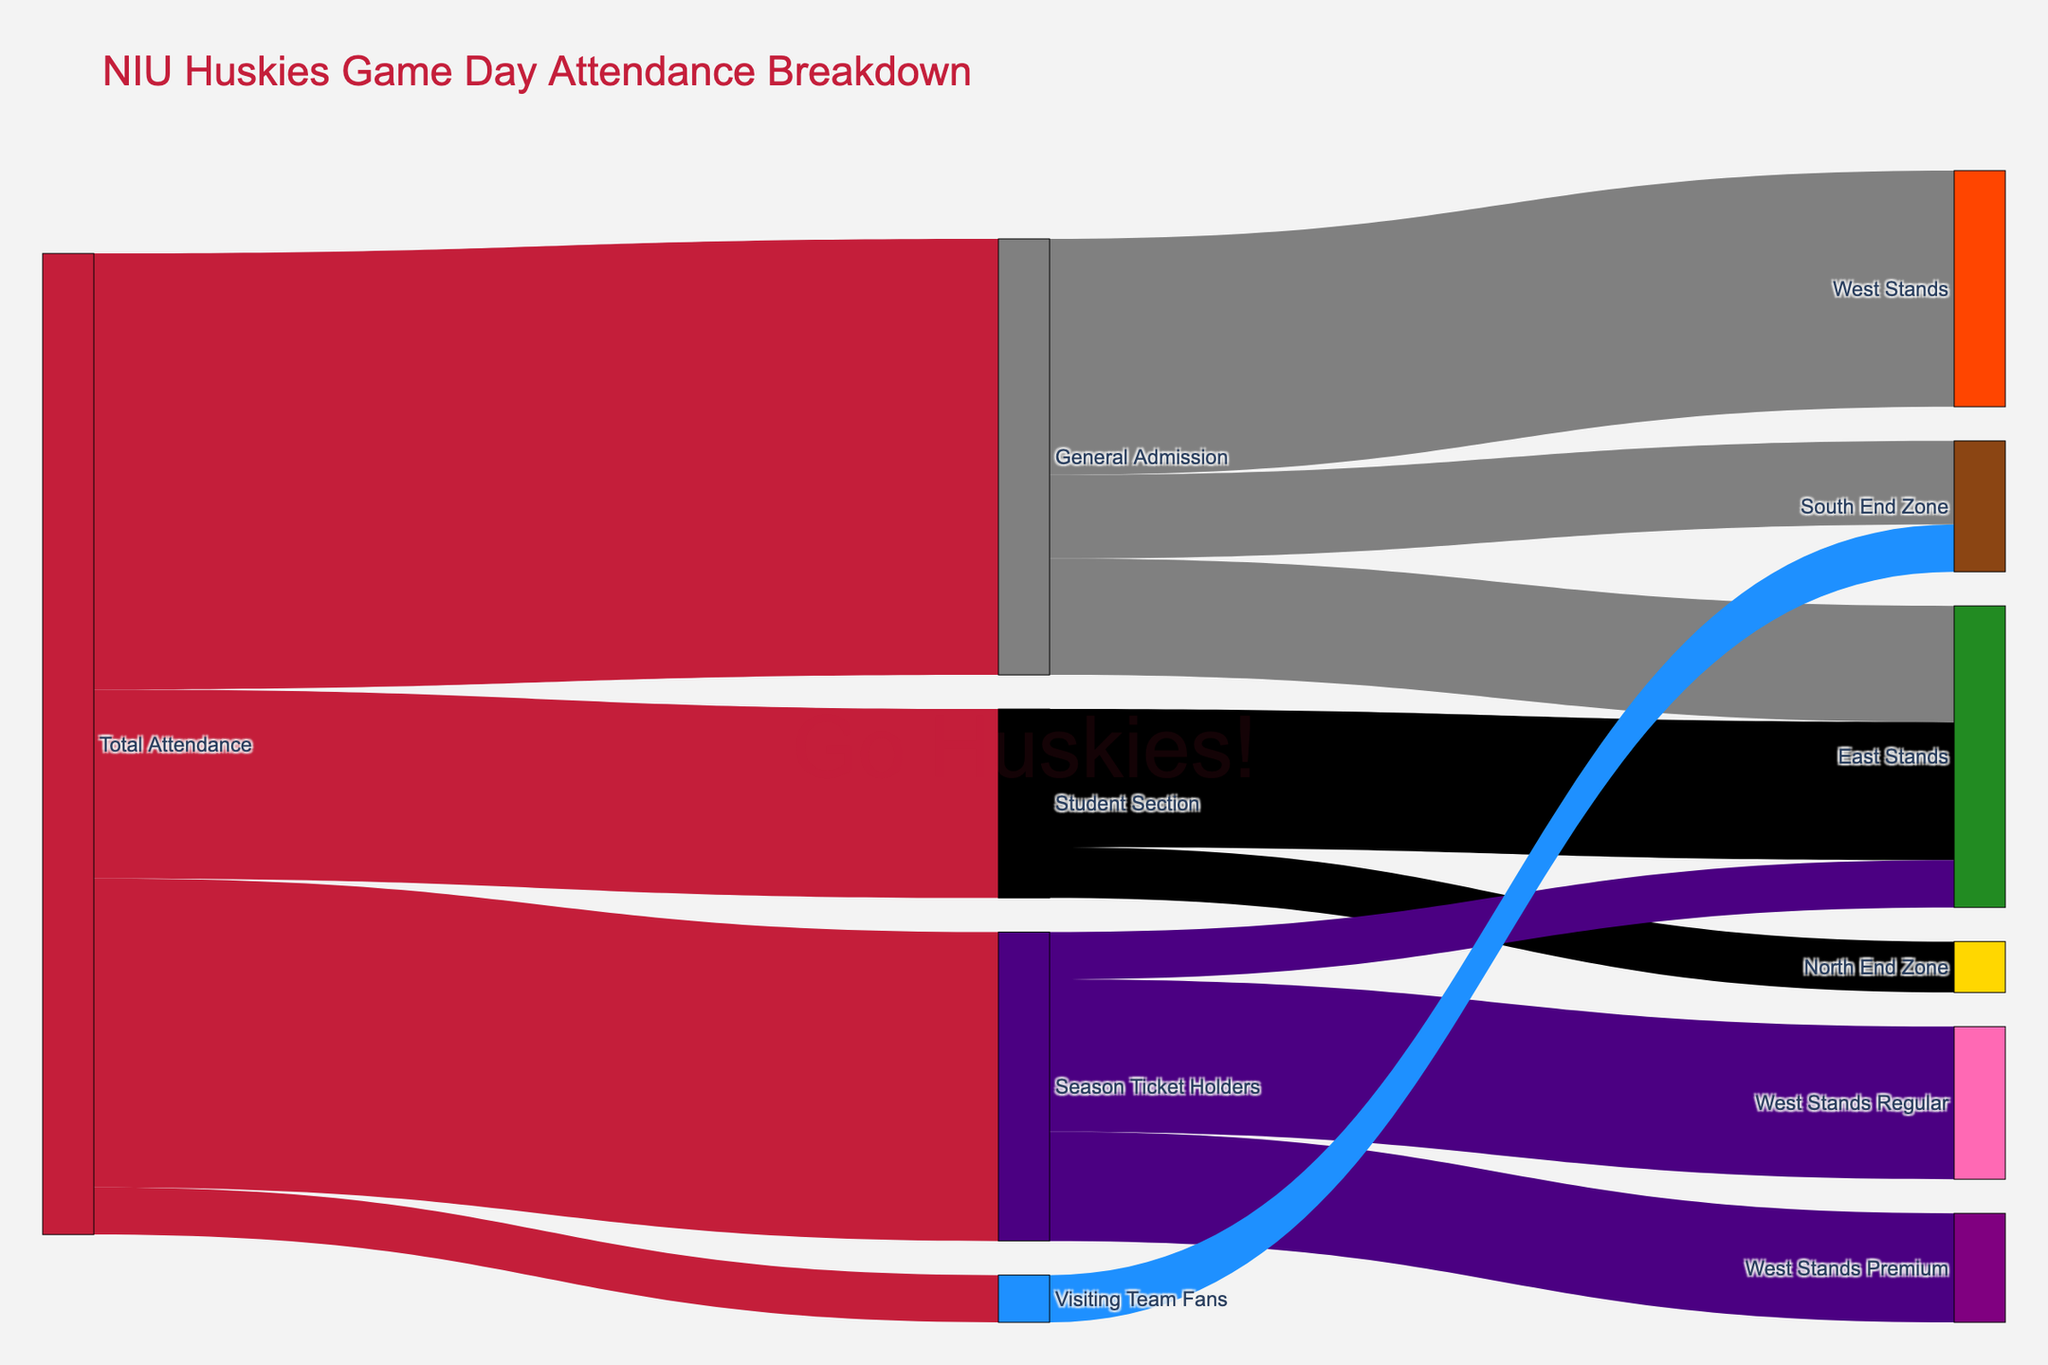What's the total attendance at the game? The source labeled "Total Attendance" flows into different sections of seating. Sum up all the values flowing from "Total Attendance": 5200 (Student Section) + 12000 (General Admission) + 8500 (Season Ticket Holders) + 1300 (Visiting Team Fans).
Answer: 27,000 How many fans are in the Student Section's East Stands? Look for the value connecting "Student Section" to "East Stands".
Answer: 3,800 Which section holds the largest number of General Admission fans? Check the values under "General Admission". The largest value is for "West Stands" with 6,500.
Answer: West Stands Among the Season Ticket Holders, which subsection has the least amount of fans? Examine the values under "Season Ticket Holders". The smallest value is for "East Stands" with 1,300.
Answer: East Stands What is the total number of fans in the South End Zone? Sum up the fans from "General Admission" and "Visiting Team Fans" who go to the "South End Zone": 2300 (GA) + 1300 (Visiting) = 2300 + 1300.
Answer: 3,600 How many sections does the Student Section flow into? Count the different target sections from the "Student Section": East Stands and North End Zone.
Answer: 2 What is the total number of fans sitting in any "East Stands" category? Sum up the values for all flows ending in "East Stands": 3800 (Students) + 3200 (GA) + 1300 (Season Ticket Holders) = 8300.
Answer: 8,300 How many more fans are in the West Stands Regular compared to the West Stands Premium for the Season Ticket Holders? Subtract the value for "West Stands Premium" from "West Stands Regular": 4200 - 3000.
Answer: 1,200 Compare the number of students in the North End Zone to the number of visiting fans in the South End Zone. Which is greater? Compare 1400 (Students, North End Zone) to 1300 (Visiting, South End Zone). 1400 > 1300.
Answer: North End Zone How many total fans are in the North End Zone? Add up the values: 1400 (Students) + 0 (none indicated for GA, STH, or Visiting).
Answer: 1,400 